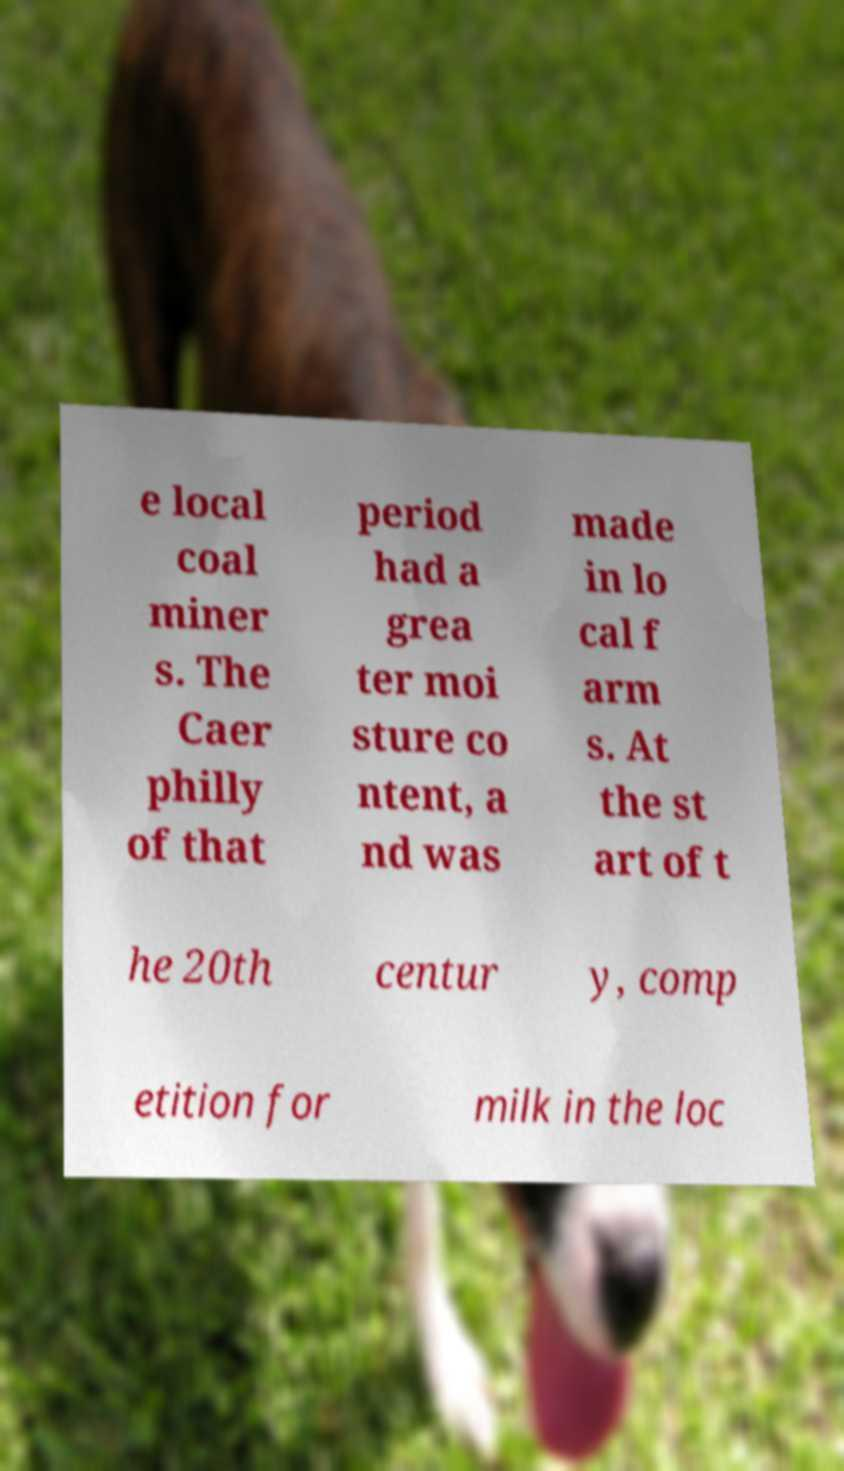Could you assist in decoding the text presented in this image and type it out clearly? e local coal miner s. The Caer philly of that period had a grea ter moi sture co ntent, a nd was made in lo cal f arm s. At the st art of t he 20th centur y, comp etition for milk in the loc 